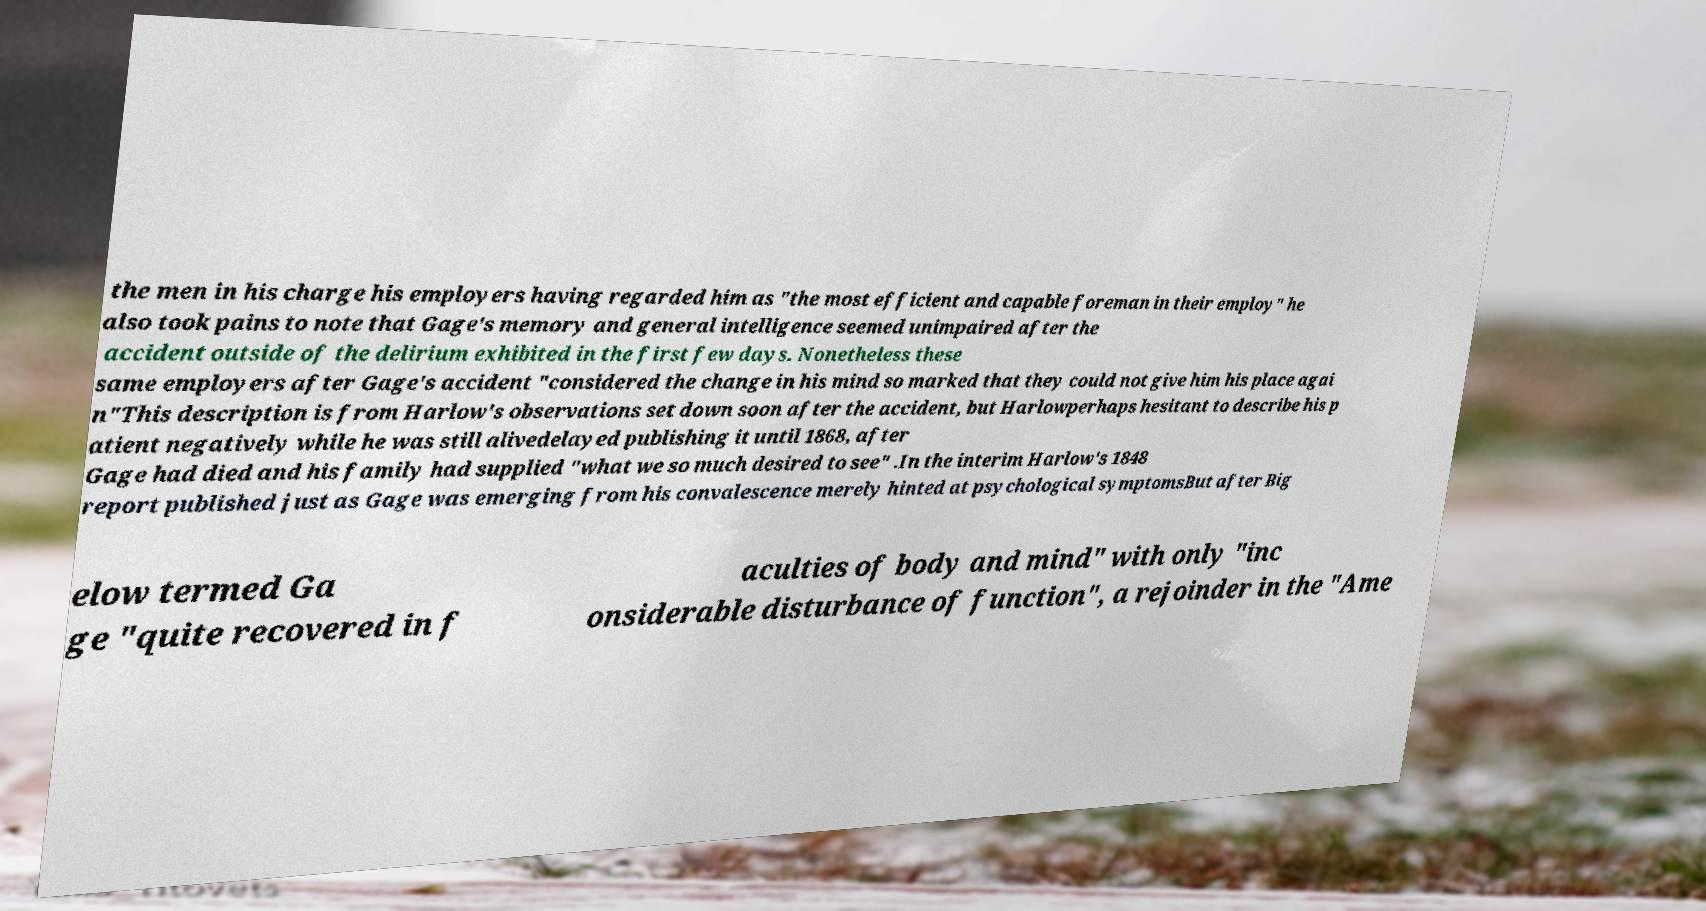Can you read and provide the text displayed in the image?This photo seems to have some interesting text. Can you extract and type it out for me? the men in his charge his employers having regarded him as "the most efficient and capable foreman in their employ" he also took pains to note that Gage's memory and general intelligence seemed unimpaired after the accident outside of the delirium exhibited in the first few days. Nonetheless these same employers after Gage's accident "considered the change in his mind so marked that they could not give him his place agai n"This description is from Harlow's observations set down soon after the accident, but Harlowperhaps hesitant to describe his p atient negatively while he was still alivedelayed publishing it until 1868, after Gage had died and his family had supplied "what we so much desired to see" .In the interim Harlow's 1848 report published just as Gage was emerging from his convalescence merely hinted at psychological symptomsBut after Big elow termed Ga ge "quite recovered in f aculties of body and mind" with only "inc onsiderable disturbance of function", a rejoinder in the "Ame 